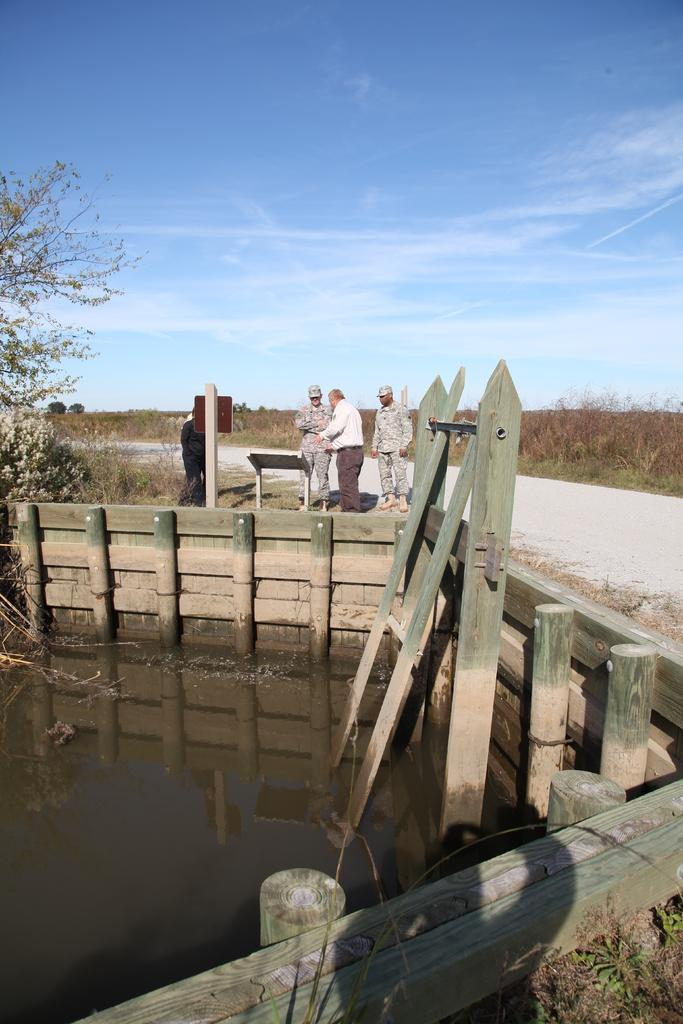What is located at the bottom of the image? There are plants, water, and a fence at the bottom of the image. What can be seen in the middle of the image? There are people, a table, a signboard, trees, plants, a road, sky, and clouds visible in the middle of the image. Can you see a beetle crawling on the signboard in the image? There is no beetle visible on the signboard in the image. Is there a window in the middle of the image? There is no window present in the image. 